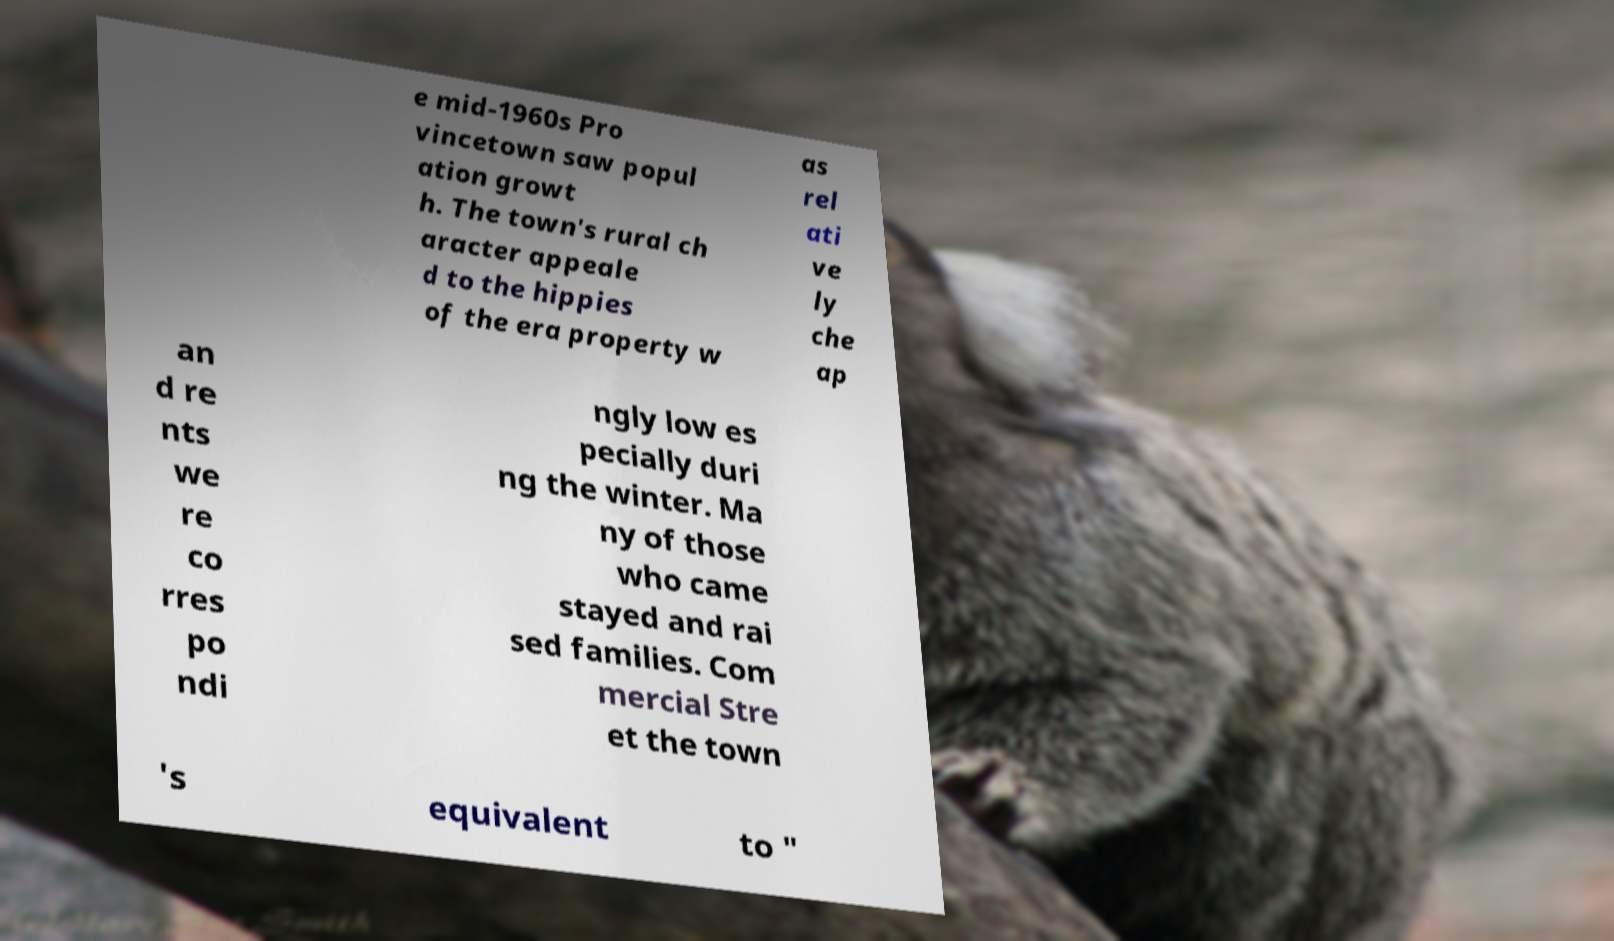Please read and relay the text visible in this image. What does it say? e mid-1960s Pro vincetown saw popul ation growt h. The town's rural ch aracter appeale d to the hippies of the era property w as rel ati ve ly che ap an d re nts we re co rres po ndi ngly low es pecially duri ng the winter. Ma ny of those who came stayed and rai sed families. Com mercial Stre et the town 's equivalent to " 